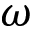<formula> <loc_0><loc_0><loc_500><loc_500>\omega</formula> 